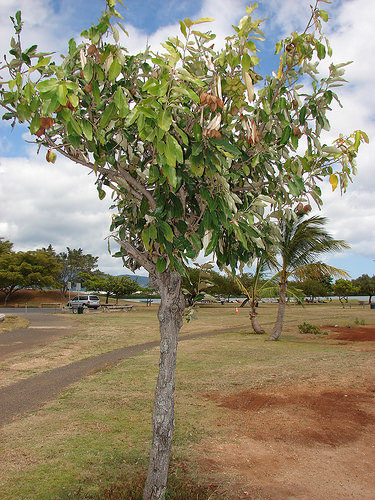<image>
Is there a tree in front of the path? Yes. The tree is positioned in front of the path, appearing closer to the camera viewpoint. 